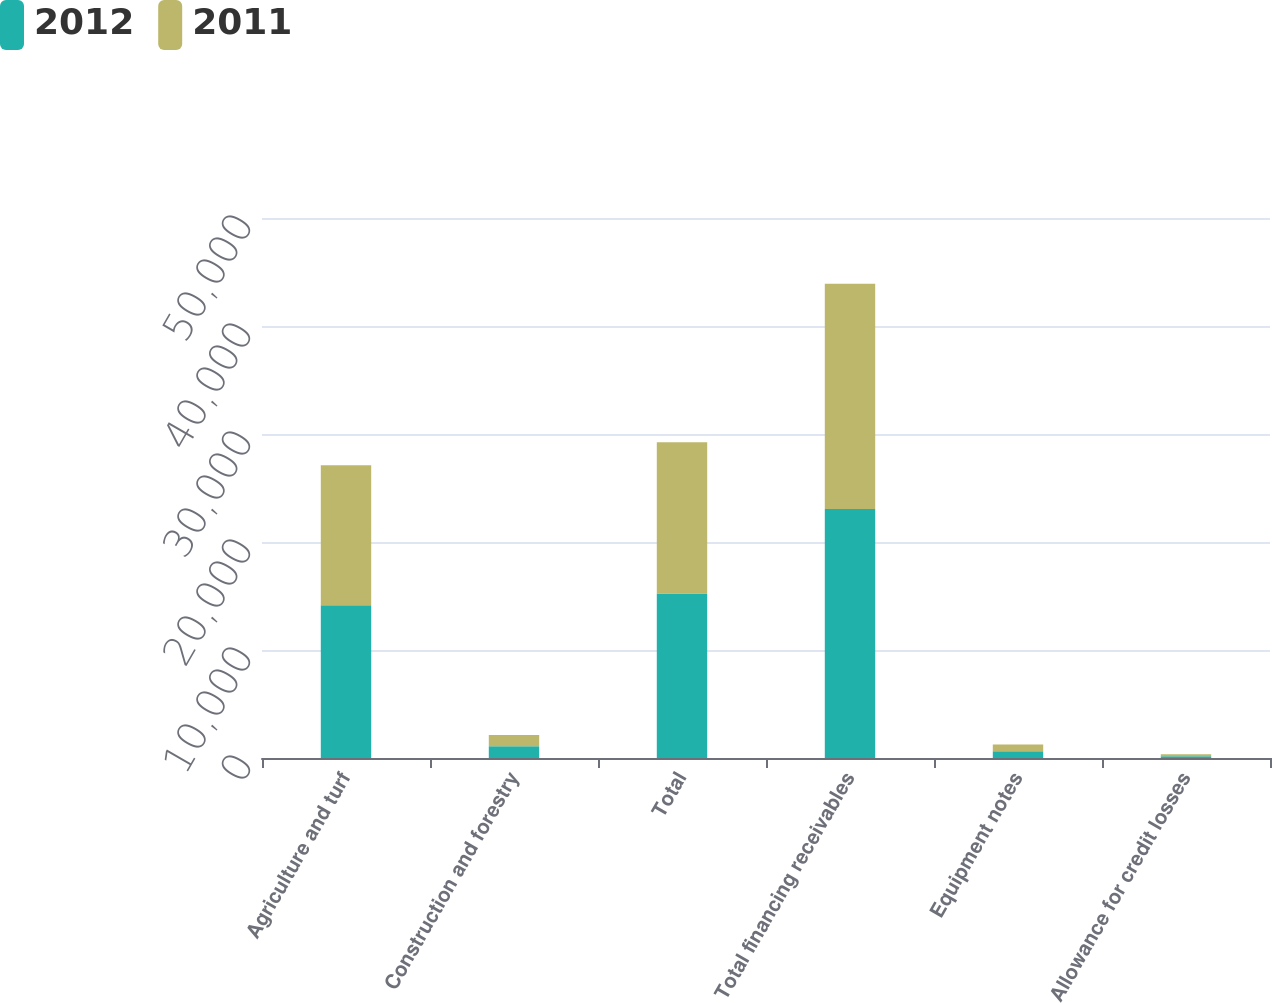Convert chart. <chart><loc_0><loc_0><loc_500><loc_500><stacked_bar_chart><ecel><fcel>Agriculture and turf<fcel>Construction and forestry<fcel>Total<fcel>Total financing receivables<fcel>Equipment notes<fcel>Allowance for credit losses<nl><fcel>2012<fcel>14144<fcel>1091<fcel>15235<fcel>23064<fcel>619<fcel>160<nl><fcel>2011<fcel>12969<fcel>1036<fcel>14009<fcel>20859<fcel>635<fcel>179<nl></chart> 